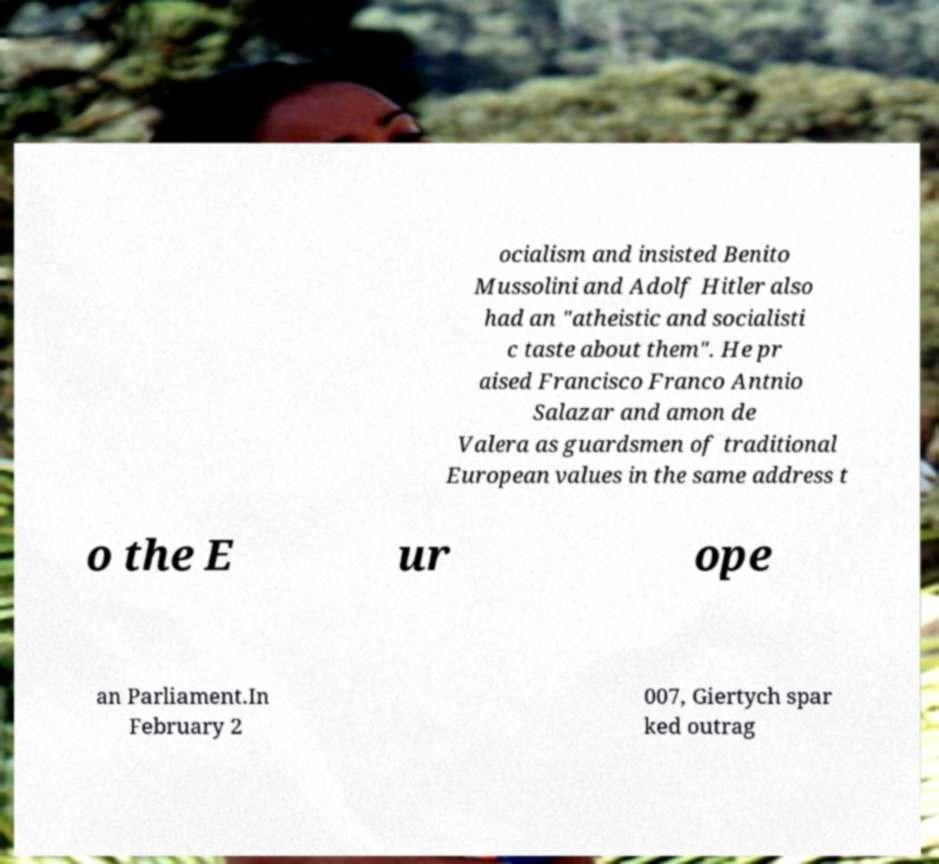Please read and relay the text visible in this image. What does it say? ocialism and insisted Benito Mussolini and Adolf Hitler also had an "atheistic and socialisti c taste about them". He pr aised Francisco Franco Antnio Salazar and amon de Valera as guardsmen of traditional European values in the same address t o the E ur ope an Parliament.In February 2 007, Giertych spar ked outrag 